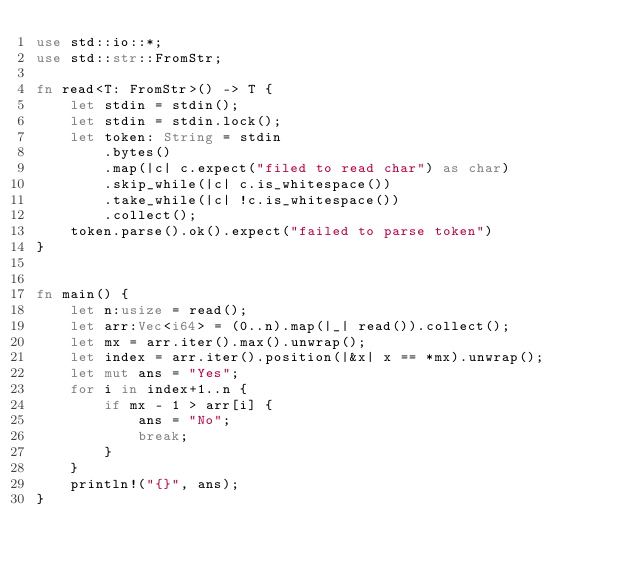Convert code to text. <code><loc_0><loc_0><loc_500><loc_500><_Rust_>use std::io::*;
use std::str::FromStr;

fn read<T: FromStr>() -> T {
    let stdin = stdin();
    let stdin = stdin.lock();
    let token: String = stdin
        .bytes()
        .map(|c| c.expect("filed to read char") as char)
        .skip_while(|c| c.is_whitespace())
        .take_while(|c| !c.is_whitespace())
        .collect();
    token.parse().ok().expect("failed to parse token")
}


fn main() {
    let n:usize = read();
    let arr:Vec<i64> = (0..n).map(|_| read()).collect();
    let mx = arr.iter().max().unwrap();
    let index = arr.iter().position(|&x| x == *mx).unwrap();
    let mut ans = "Yes";
    for i in index+1..n {
        if mx - 1 > arr[i] {
            ans = "No";
            break;
        }
    }
    println!("{}", ans);
}
</code> 